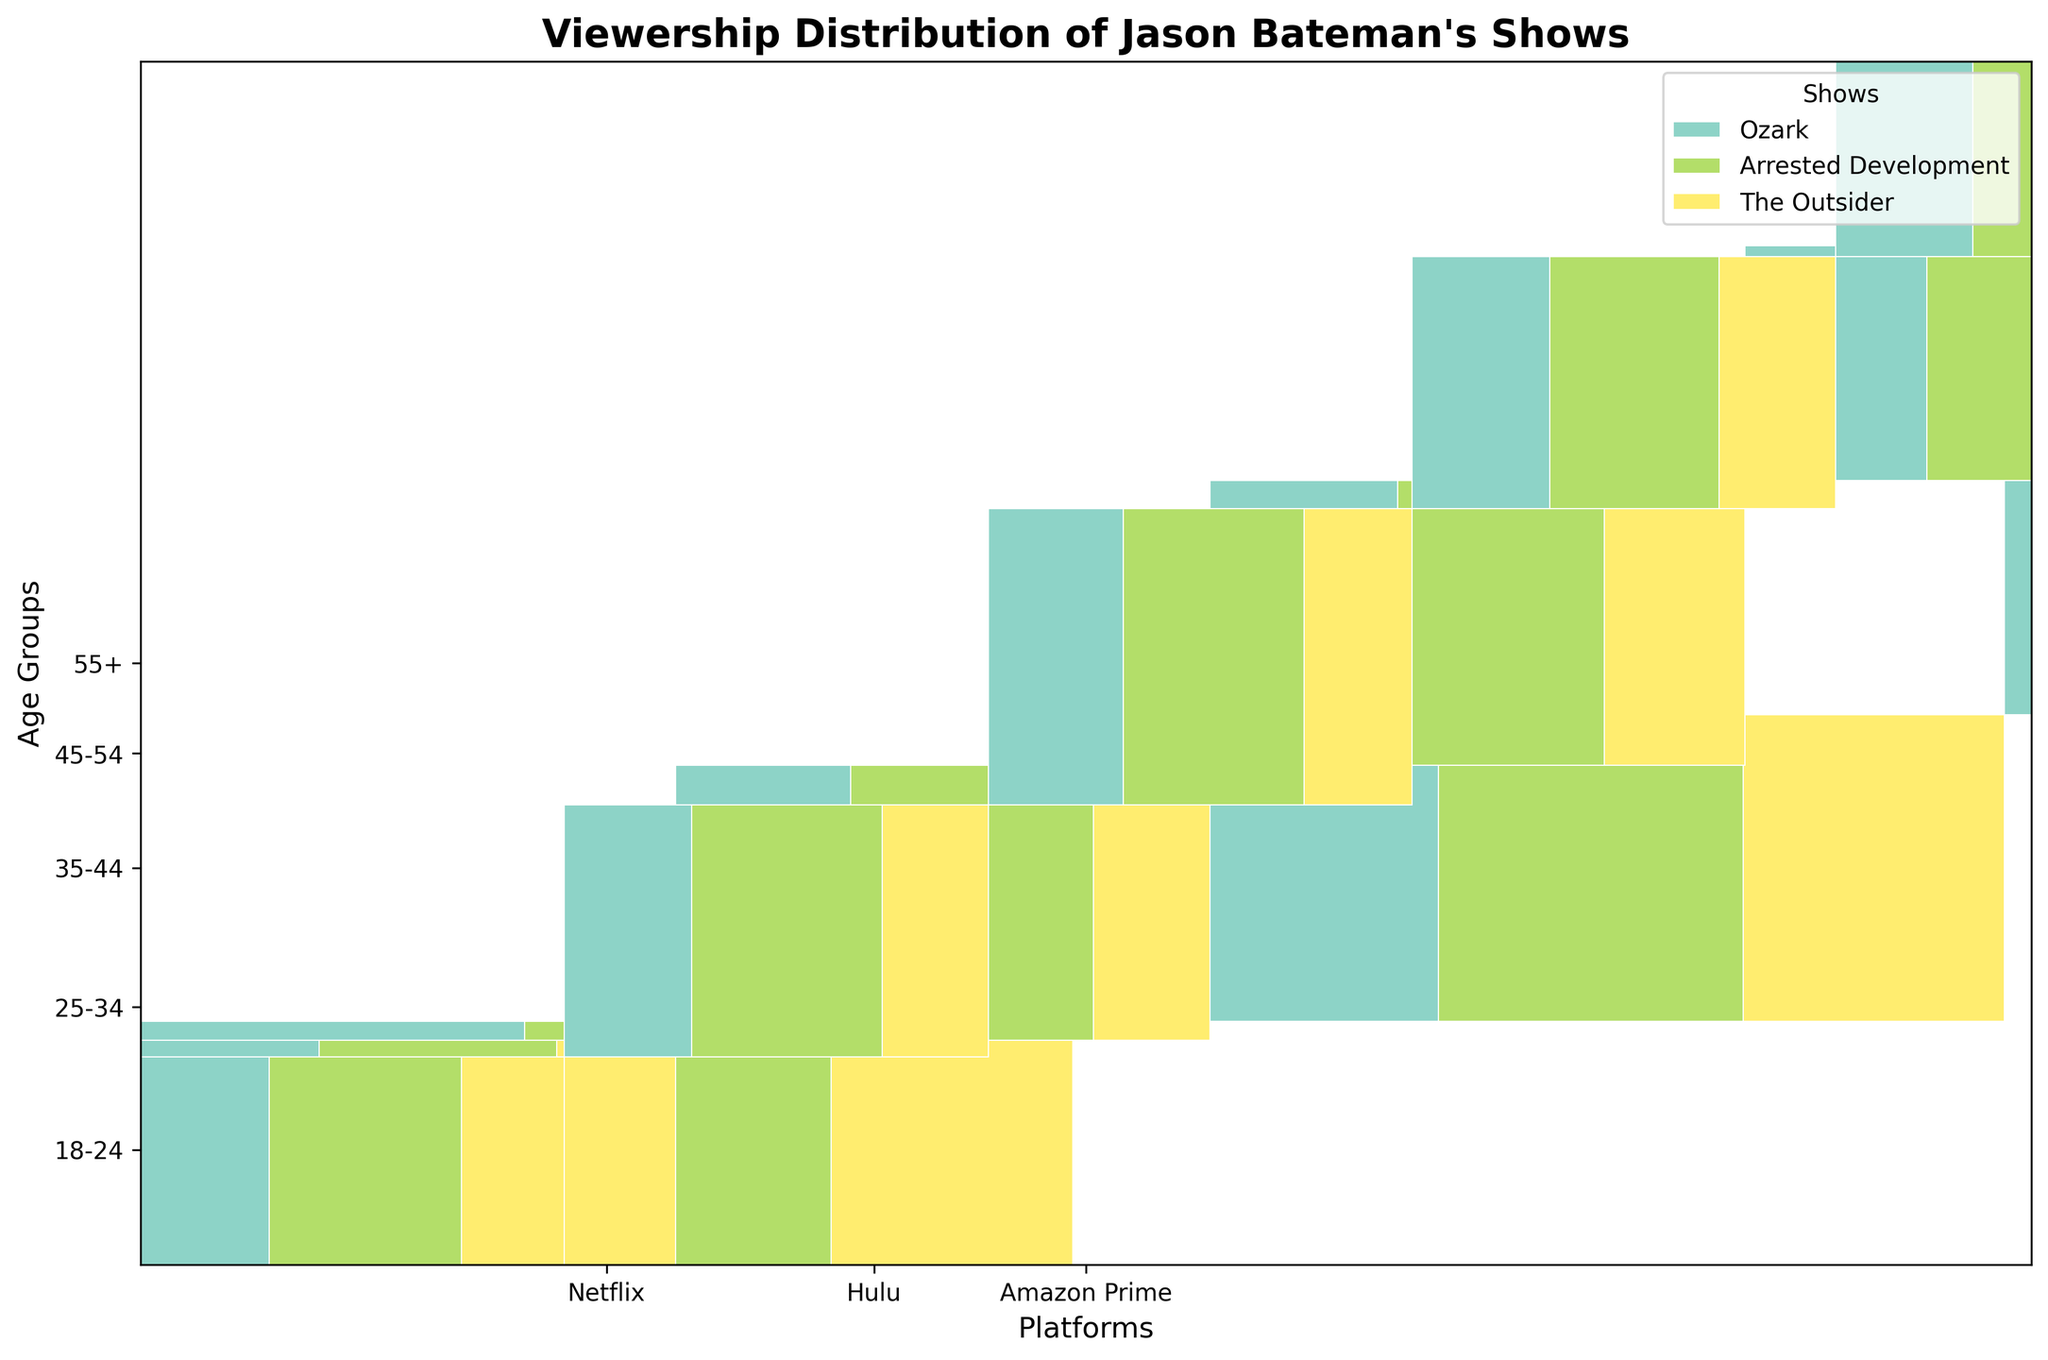What is the most popular show among the 18-24 age group on Netflix? In the 18-24 age group on Netflix, sum the values for 'Ozark', 'Arrested Development', and 'The Outsider', and compare them. 'Ozark' has 35 viewers, 'Arrested Development' has 28 viewers, and 'The Outsider' has 22 viewers.
Answer: Ozark Which platform has the highest total viewership for Jason Bateman's shows in the 25-34 age group? Sum the total viewership for 'Ozark', 'Arrested Development', and 'The Outsider' on each platform for the 25-34 age group. Netflix has 42 + 35 + 30 = 107, Hulu has 18 + 25 + 12 = 55, and Amazon Prime has 12 + 18 + 10 = 40.
Answer: Netflix Between the 18-24 and 55+ age groups on Hulu, which has more viewers for 'Arrested Development'? Compare the viewership values for 'Arrested Development' on Hulu in the 18-24 and 55+ age groups. The 18-24 age group has 20 viewers, and the 55+ age group has 15 viewers.
Answer: 18-24 What percentage of the total viewership for 'The Outsider' on Amazon Prime comes from the 35-44 age group? Calculate the total viewership of 'The Outsider' on Amazon Prime, then find the percentage contributed by the 35-44 age group. The total viewership is 8 (18-24) + 10 (25-34) + 12 (35-44) + 11 (45-54) + 9 (55+) = 50. The 35-44 age group has 12 viewers. (12 / 50) * 100 = 24%.
Answer: 24% On which platform does 'Ozark' have the lowest viewership among the 18-24 age group? Compare the viewership values for 'Ozark' in the 18-24 age group across all platforms. Netflix has 35 viewers, Hulu has 15, and Amazon Prime has 10.
Answer: Amazon Prime Which age group contributes the least to the total viewership of 'The Outsider' on Hulu? Sum the viewership of 'The Outsider' for each age group on Hulu and identify the smallest value. The age groups have: 18-24 = 10, 25-34 = 12, 35-44 = 15, 45-54 = 13, 55+ = 10. The least is: 10
Answer: 18-24 and 55+ How does the viewership of 'Arrested Development' on Netflix for the 35-44 age group compare to the 45-54 age group? Determine the viewership values for 'Arrested Development' on Netflix for both age groups. The 35-44 age group has 30 viewers, and the 45-54 age group has 25 viewers.
Answer: Higher by 5 What fraction of the total viewership for 'Ozark' on Hulu comes from the 25-34 age group? Calculate the total viewership of 'Ozark' on Hulu, then find the fraction from the 25-34 age group. The total is 15 (18-24) + 18 (25-34) + 20 (35-44) + 16 (45-54) + 12 (55+) = 81. The 25-34 age group has 18 viewers. Fraction = 18 / 81.
Answer: 2/9 